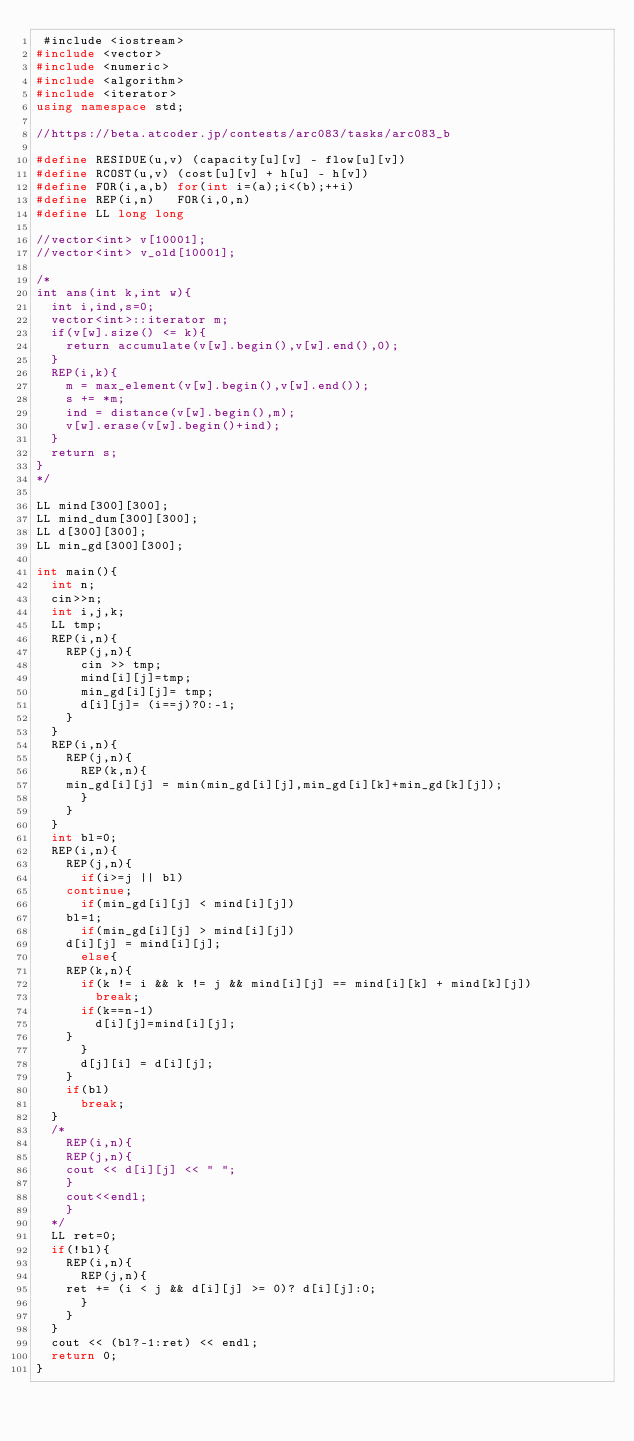Convert code to text. <code><loc_0><loc_0><loc_500><loc_500><_C++_> #include <iostream>
#include <vector>
#include <numeric>
#include <algorithm>
#include <iterator>
using namespace std;

//https://beta.atcoder.jp/contests/arc083/tasks/arc083_b

#define RESIDUE(u,v) (capacity[u][v] - flow[u][v])
#define RCOST(u,v) (cost[u][v] + h[u] - h[v])
#define FOR(i,a,b) for(int i=(a);i<(b);++i)
#define REP(i,n)   FOR(i,0,n)
#define LL long long

//vector<int> v[10001];
//vector<int> v_old[10001];

/*
int ans(int k,int w){
  int i,ind,s=0;
  vector<int>::iterator m;
  if(v[w].size() <= k){
    return accumulate(v[w].begin(),v[w].end(),0);
  }
  REP(i,k){
    m = max_element(v[w].begin(),v[w].end());
    s += *m;
    ind = distance(v[w].begin(),m);
    v[w].erase(v[w].begin()+ind);
  }
  return s;
}
*/

LL mind[300][300];
LL mind_dum[300][300];
LL d[300][300];
LL min_gd[300][300];

int main(){
  int n;
  cin>>n;
  int i,j,k;
  LL tmp;
  REP(i,n){
    REP(j,n){
      cin >> tmp;
      mind[i][j]=tmp;
      min_gd[i][j]= tmp;
      d[i][j]= (i==j)?0:-1;
    }
  }
  REP(i,n){
    REP(j,n){
      REP(k,n){
	min_gd[i][j] = min(min_gd[i][j],min_gd[i][k]+min_gd[k][j]);
      }
    }
  }
  int bl=0;
  REP(i,n){
    REP(j,n){
      if(i>=j || bl)
	continue;
      if(min_gd[i][j] < mind[i][j])
	bl=1;
      if(min_gd[i][j] > mind[i][j])
	d[i][j] = mind[i][j];
      else{
	REP(k,n){
	  if(k != i && k != j && mind[i][j] == mind[i][k] + mind[k][j])
	    break;
	  if(k==n-1)
	    d[i][j]=mind[i][j];
	}
      }
      d[j][i] = d[i][j];
    }
    if(bl)
      break;
  }
  /*
    REP(i,n){
    REP(j,n){
    cout << d[i][j] << " ";
    }
    cout<<endl;
    }
  */
  LL ret=0;
  if(!bl){
    REP(i,n){
      REP(j,n){
	ret += (i < j && d[i][j] >= 0)? d[i][j]:0;
      }
    }
  }
  cout << (bl?-1:ret) << endl;
  return 0;
}
</code> 